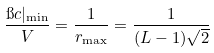Convert formula to latex. <formula><loc_0><loc_0><loc_500><loc_500>\frac { \i c | _ { \min } } { V } = \frac { 1 } { r _ { \max } } = \frac { 1 } { ( L - 1 ) \sqrt { 2 } }</formula> 